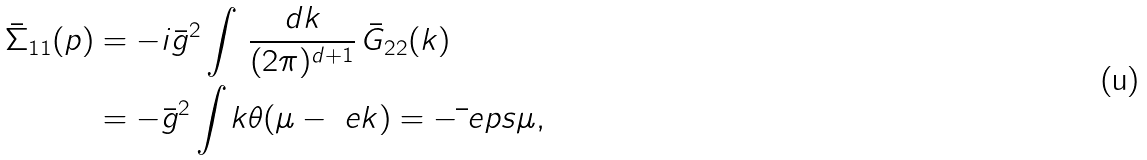<formula> <loc_0><loc_0><loc_500><loc_500>\bar { \Sigma } _ { 1 1 } ( p ) & = - i \bar { g } ^ { 2 } \int \, \frac { d k } { ( 2 \pi ) ^ { d + 1 } } \, \bar { G } _ { 2 2 } ( k ) \\ & = - \bar { g } ^ { 2 } \int _ { \ } k \theta ( \mu - \ e k ) = - \bar { \ } e p s \mu ,</formula> 